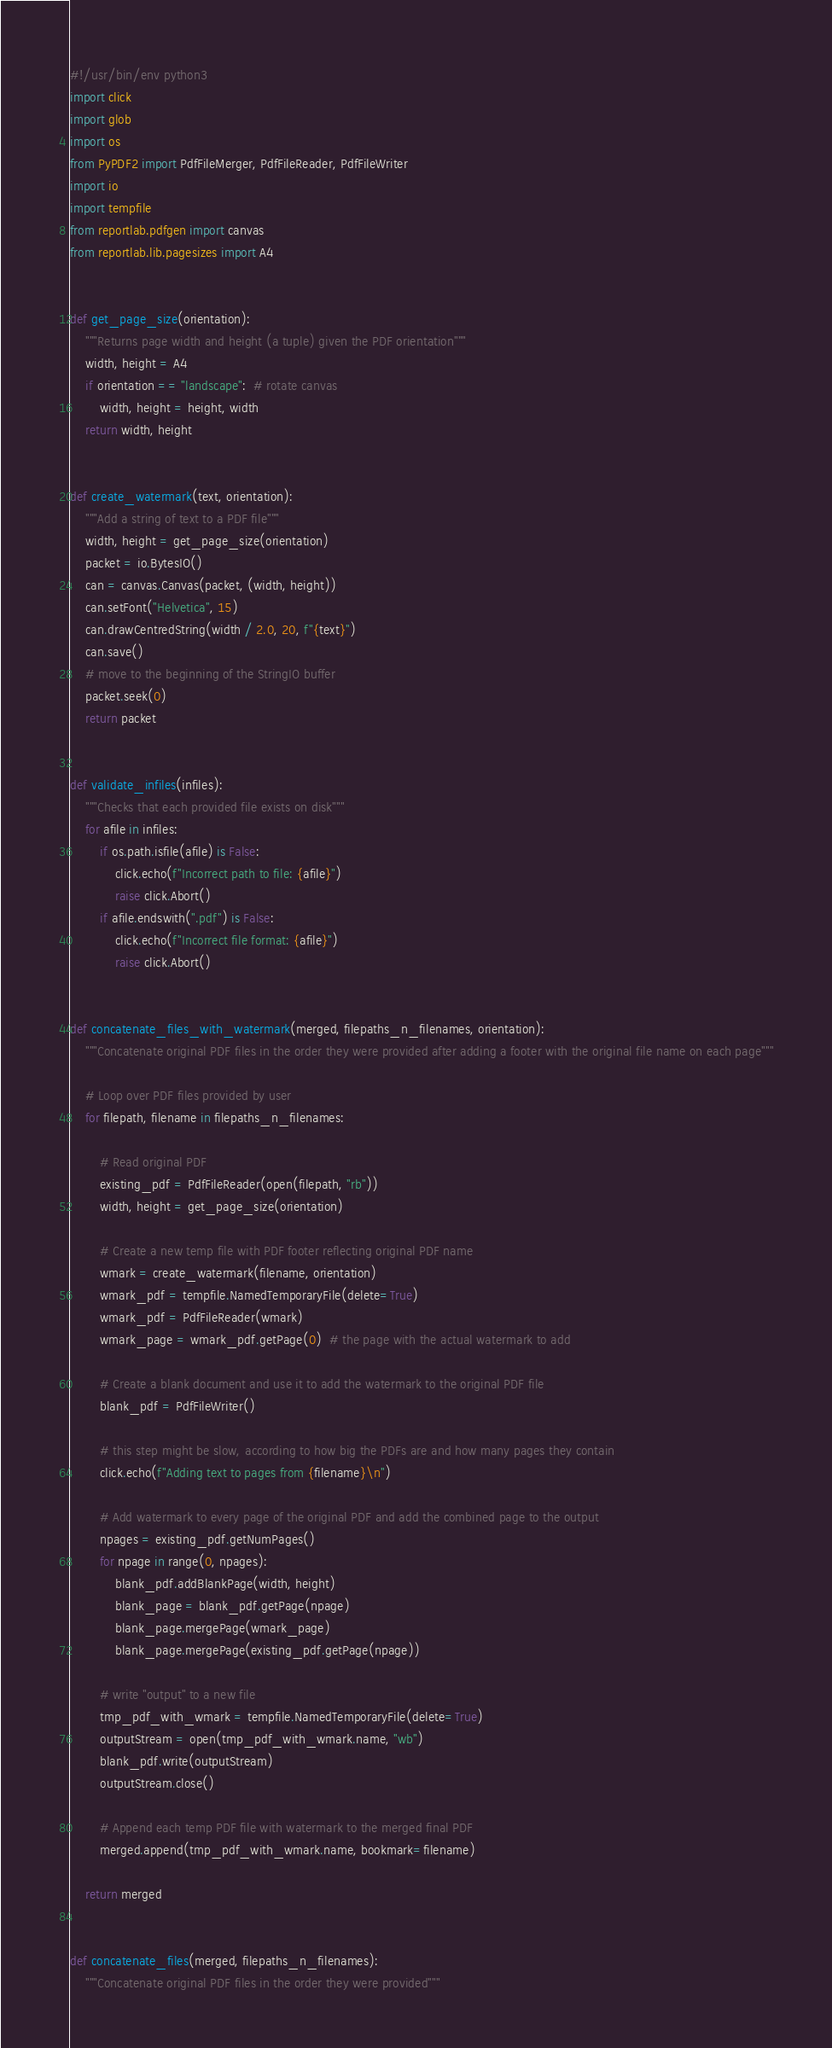<code> <loc_0><loc_0><loc_500><loc_500><_Python_>#!/usr/bin/env python3
import click
import glob
import os
from PyPDF2 import PdfFileMerger, PdfFileReader, PdfFileWriter
import io
import tempfile
from reportlab.pdfgen import canvas
from reportlab.lib.pagesizes import A4


def get_page_size(orientation):
    """Returns page width and height (a tuple) given the PDF orientation"""
    width, height = A4
    if orientation == "landscape":  # rotate canvas
        width, height = height, width
    return width, height


def create_watermark(text, orientation):
    """Add a string of text to a PDF file"""
    width, height = get_page_size(orientation)
    packet = io.BytesIO()
    can = canvas.Canvas(packet, (width, height))
    can.setFont("Helvetica", 15)
    can.drawCentredString(width / 2.0, 20, f"{text}")
    can.save()
    # move to the beginning of the StringIO buffer
    packet.seek(0)
    return packet


def validate_infiles(infiles):
    """Checks that each provided file exists on disk"""
    for afile in infiles:
        if os.path.isfile(afile) is False:
            click.echo(f"Incorrect path to file: {afile}")
            raise click.Abort()
        if afile.endswith(".pdf") is False:
            click.echo(f"Incorrect file format: {afile}")
            raise click.Abort()


def concatenate_files_with_watermark(merged, filepaths_n_filenames, orientation):
    """Concatenate original PDF files in the order they were provided after adding a footer with the original file name on each page"""

    # Loop over PDF files provided by user
    for filepath, filename in filepaths_n_filenames:

        # Read original PDF
        existing_pdf = PdfFileReader(open(filepath, "rb"))
        width, height = get_page_size(orientation)

        # Create a new temp file with PDF footer reflecting original PDF name
        wmark = create_watermark(filename, orientation)
        wmark_pdf = tempfile.NamedTemporaryFile(delete=True)
        wmark_pdf = PdfFileReader(wmark)
        wmark_page = wmark_pdf.getPage(0)  # the page with the actual watermark to add

        # Create a blank document and use it to add the watermark to the original PDF file
        blank_pdf = PdfFileWriter()

        # this step might be slow, according to how big the PDFs are and how many pages they contain
        click.echo(f"Adding text to pages from {filename}\n")

        # Add watermark to every page of the original PDF and add the combined page to the output
        npages = existing_pdf.getNumPages()
        for npage in range(0, npages):
            blank_pdf.addBlankPage(width, height)
            blank_page = blank_pdf.getPage(npage)
            blank_page.mergePage(wmark_page)
            blank_page.mergePage(existing_pdf.getPage(npage))

        # write "output" to a new file
        tmp_pdf_with_wmark = tempfile.NamedTemporaryFile(delete=True)
        outputStream = open(tmp_pdf_with_wmark.name, "wb")
        blank_pdf.write(outputStream)
        outputStream.close()

        # Append each temp PDF file with watermark to the merged final PDF
        merged.append(tmp_pdf_with_wmark.name, bookmark=filename)

    return merged


def concatenate_files(merged, filepaths_n_filenames):
    """Concatenate original PDF files in the order they were provided"""
</code> 